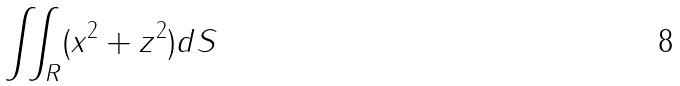<formula> <loc_0><loc_0><loc_500><loc_500>\iint _ { R } ( x ^ { 2 } + z ^ { 2 } ) d S</formula> 